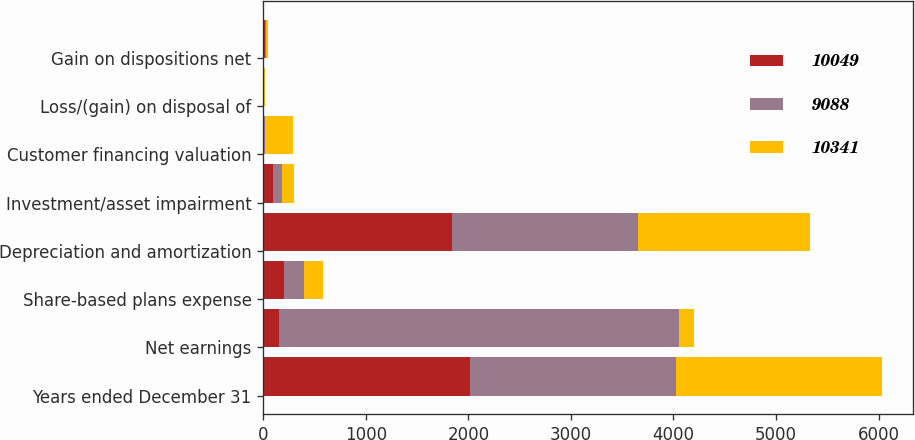<chart> <loc_0><loc_0><loc_500><loc_500><stacked_bar_chart><ecel><fcel>Years ended December 31<fcel>Net earnings<fcel>Share-based plans expense<fcel>Depreciation and amortization<fcel>Investment/asset impairment<fcel>Customer financing valuation<fcel>Loss/(gain) on disposal of<fcel>Gain on dispositions net<nl><fcel>10049<fcel>2013<fcel>152.5<fcel>206<fcel>1844<fcel>96<fcel>11<fcel>1<fcel>20<nl><fcel>9088<fcel>2012<fcel>3900<fcel>193<fcel>1811<fcel>84<fcel>10<fcel>5<fcel>4<nl><fcel>10341<fcel>2011<fcel>152.5<fcel>186<fcel>1675<fcel>119<fcel>269<fcel>11<fcel>24<nl></chart> 